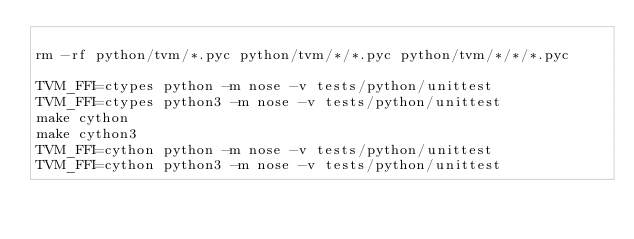Convert code to text. <code><loc_0><loc_0><loc_500><loc_500><_Bash_>
rm -rf python/tvm/*.pyc python/tvm/*/*.pyc python/tvm/*/*/*.pyc

TVM_FFI=ctypes python -m nose -v tests/python/unittest
TVM_FFI=ctypes python3 -m nose -v tests/python/unittest
make cython
make cython3
TVM_FFI=cython python -m nose -v tests/python/unittest
TVM_FFI=cython python3 -m nose -v tests/python/unittest
</code> 